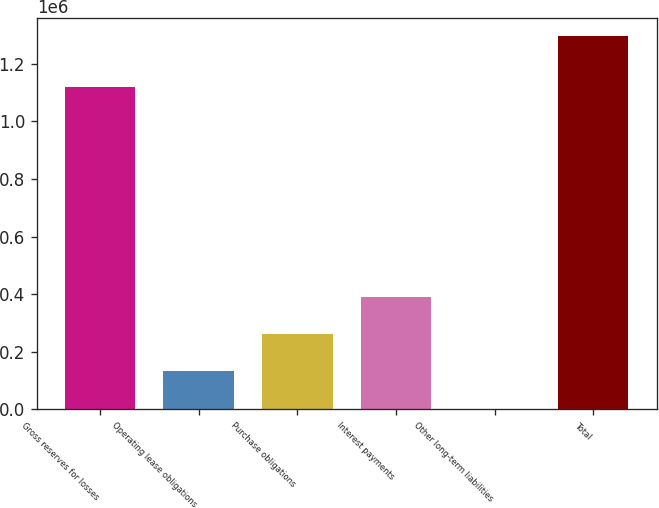<chart> <loc_0><loc_0><loc_500><loc_500><bar_chart><fcel>Gross reserves for losses<fcel>Operating lease obligations<fcel>Purchase obligations<fcel>Interest payments<fcel>Other long-term liabilities<fcel>Total<nl><fcel>1.12094e+06<fcel>131792<fcel>261036<fcel>390280<fcel>2548<fcel>1.29499e+06<nl></chart> 